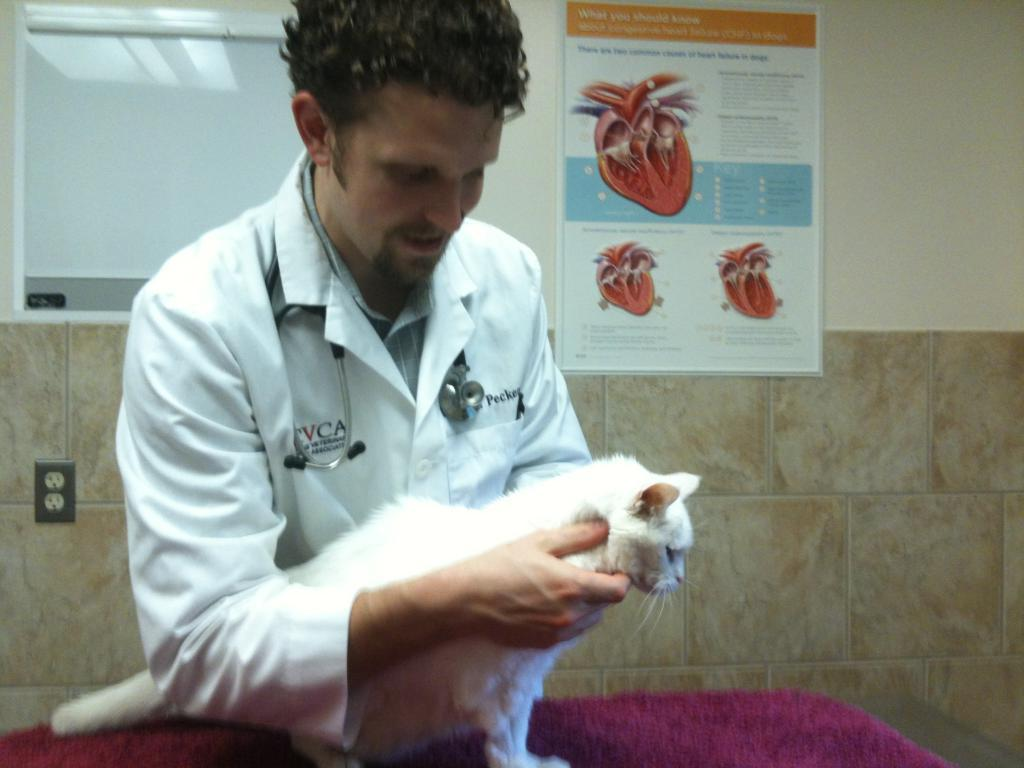What is the person in the image holding? The person is holding a white cat. What is the person wearing? The person is wearing a white shirt. What is the person wearing around their neck? The person is wearing a stethoscope. What can be seen in the background of the image? There is a photo in the background with images of a heart. What type of lock can be seen on the jar in the image? There is no jar or lock present in the image. What sound is the person making in the image? The image does not depict any sounds being made by the person. 